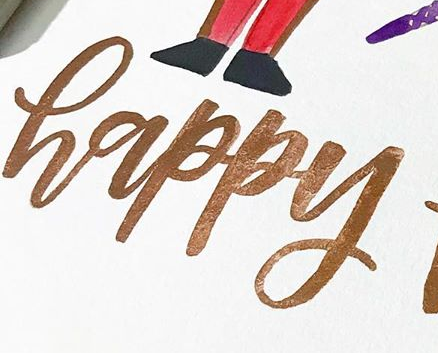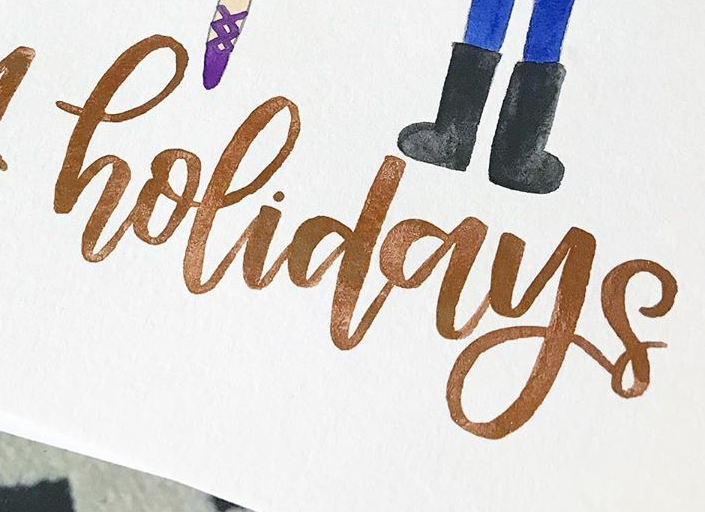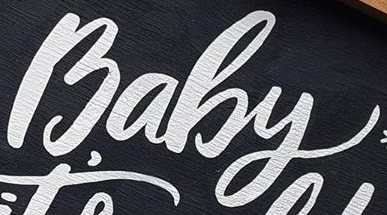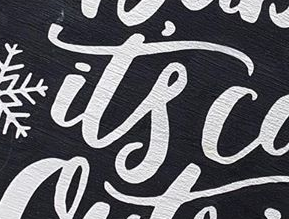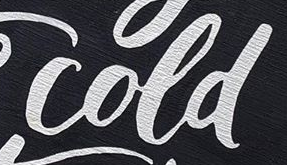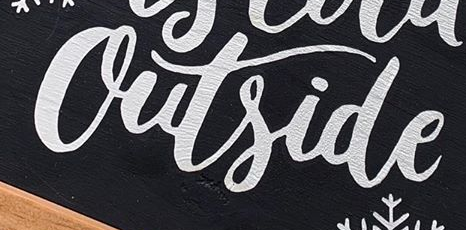What words are shown in these images in order, separated by a semicolon? happy; holidays; Baby; it's; cold; Outside 